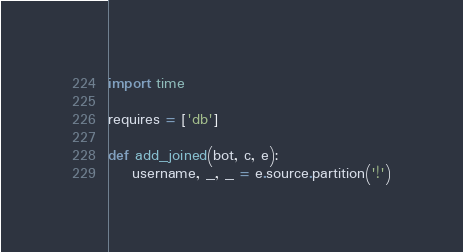<code> <loc_0><loc_0><loc_500><loc_500><_Python_>import time

requires = ['db']

def add_joined(bot, c, e):
    username, _, _ = e.source.partition('!')
</code> 